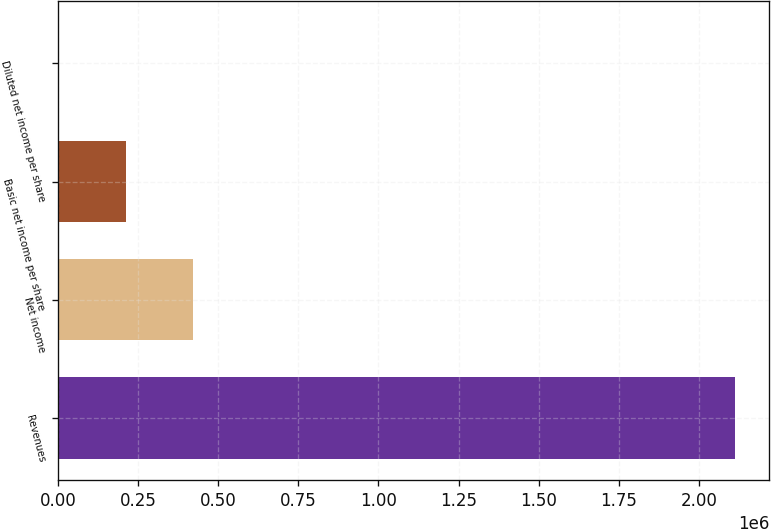Convert chart. <chart><loc_0><loc_0><loc_500><loc_500><bar_chart><fcel>Revenues<fcel>Net income<fcel>Basic net income per share<fcel>Diluted net income per share<nl><fcel>2.11359e+06<fcel>422720<fcel>211361<fcel>2.22<nl></chart> 